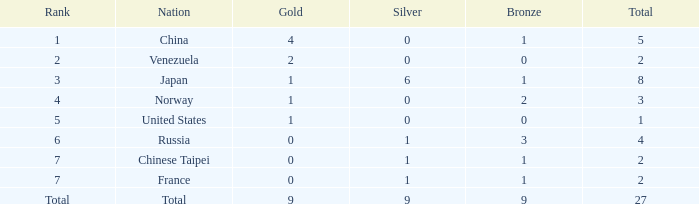What is the average Bronze for rank 3 and total is more than 8? None. 